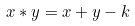Convert formula to latex. <formula><loc_0><loc_0><loc_500><loc_500>x * y = x + y - k</formula> 